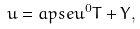Convert formula to latex. <formula><loc_0><loc_0><loc_500><loc_500>u = \L a p s e u ^ { 0 } T + Y ,</formula> 